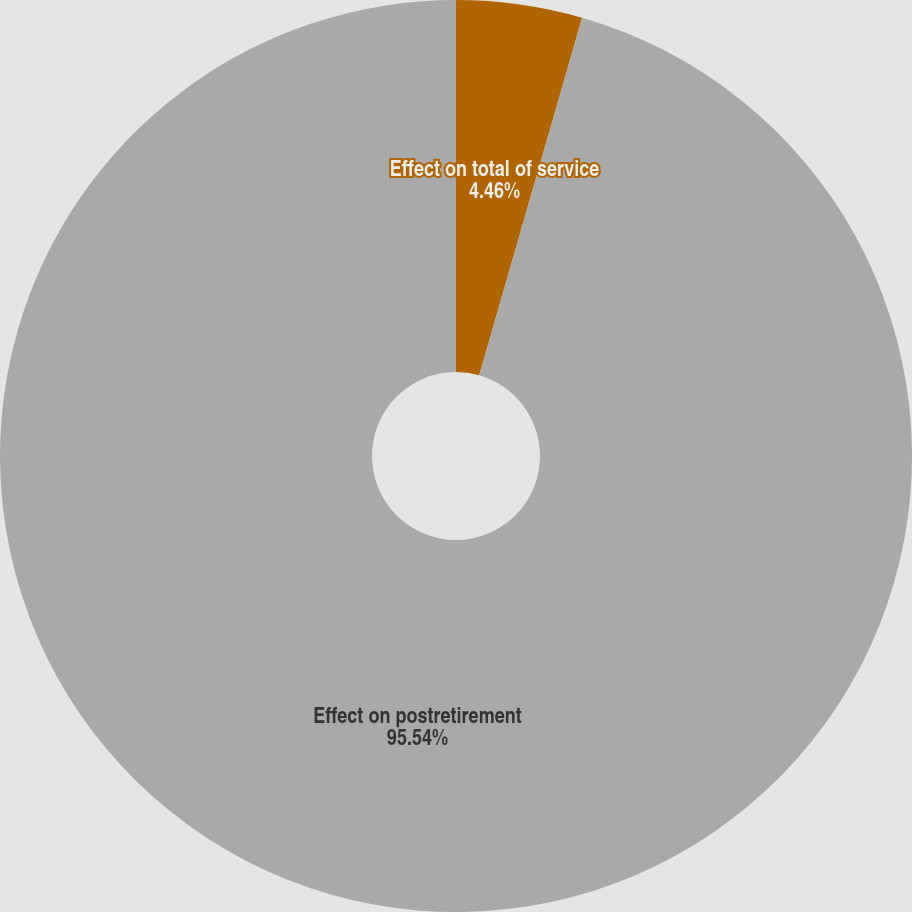<chart> <loc_0><loc_0><loc_500><loc_500><pie_chart><fcel>Effect on total of service<fcel>Effect on postretirement<nl><fcel>4.46%<fcel>95.54%<nl></chart> 